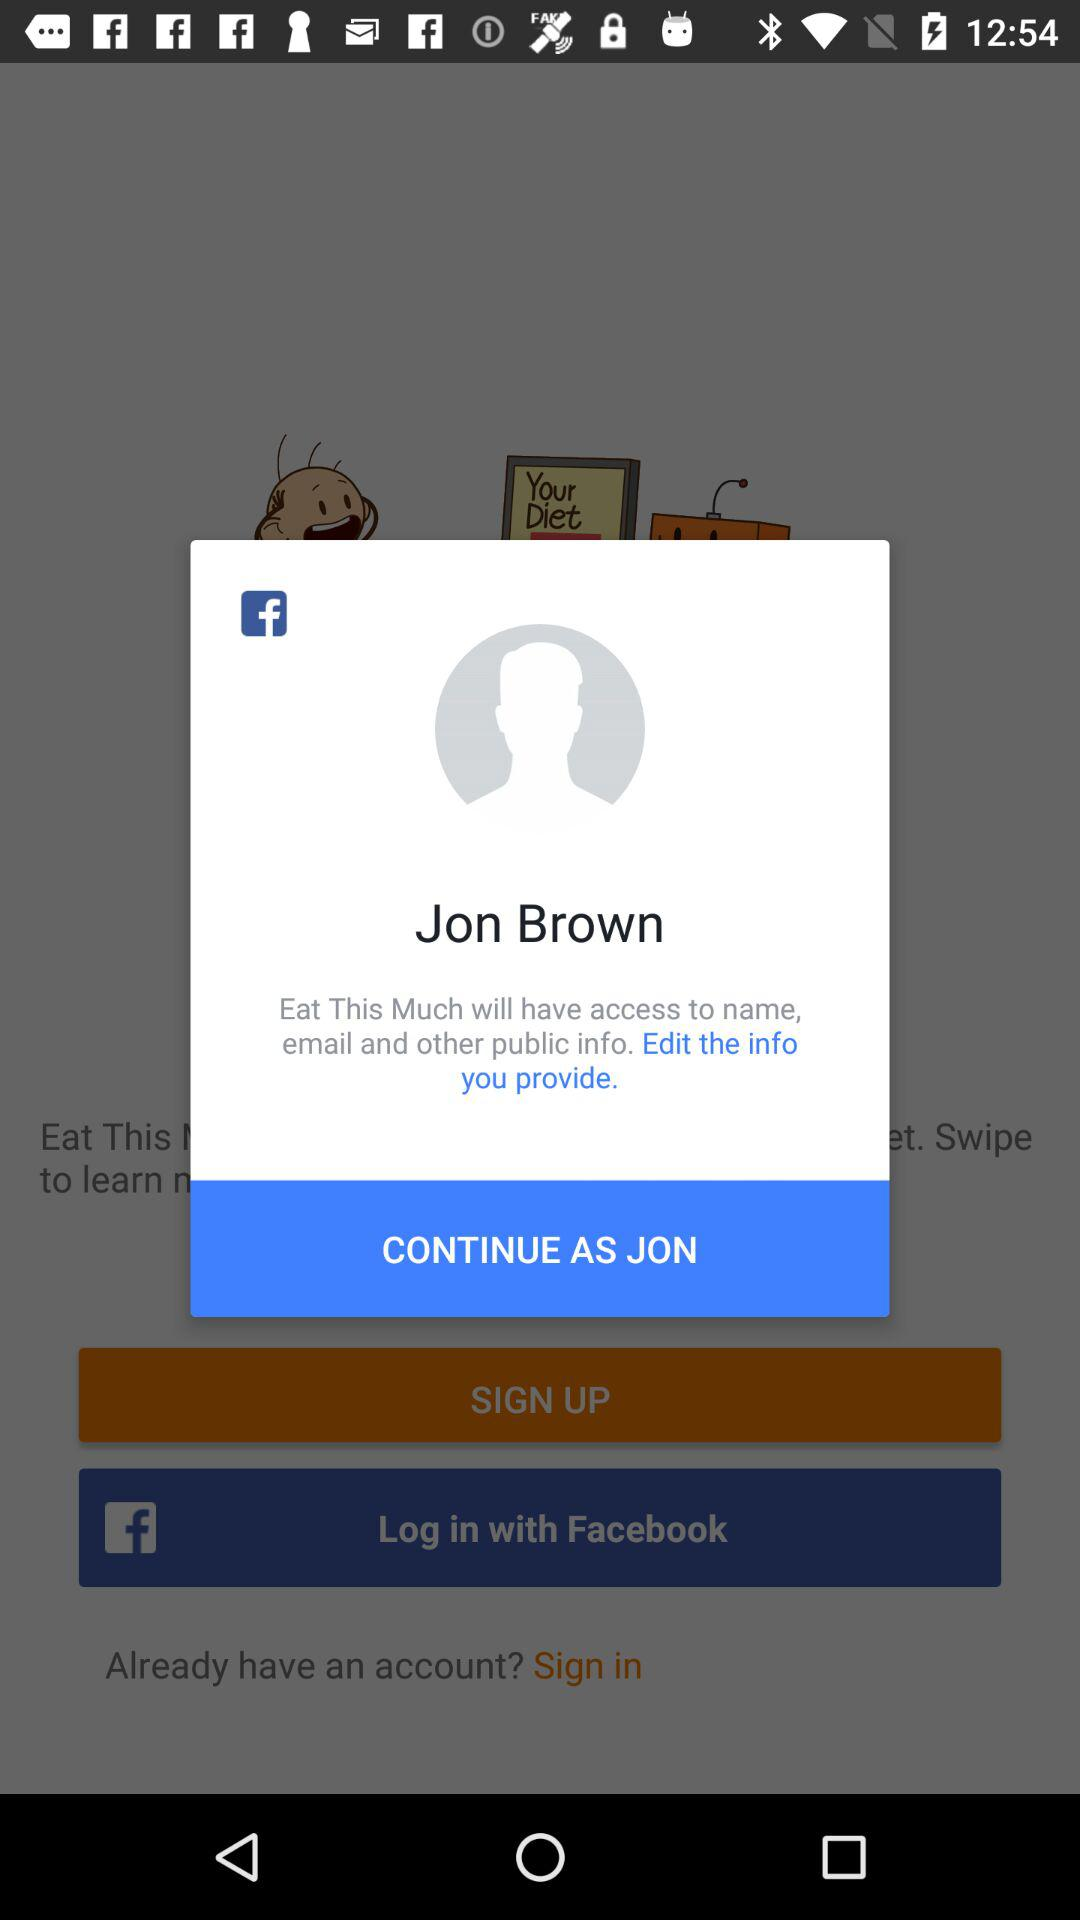What is the user name to continue on the log in page? The user name is Jon Brown. 